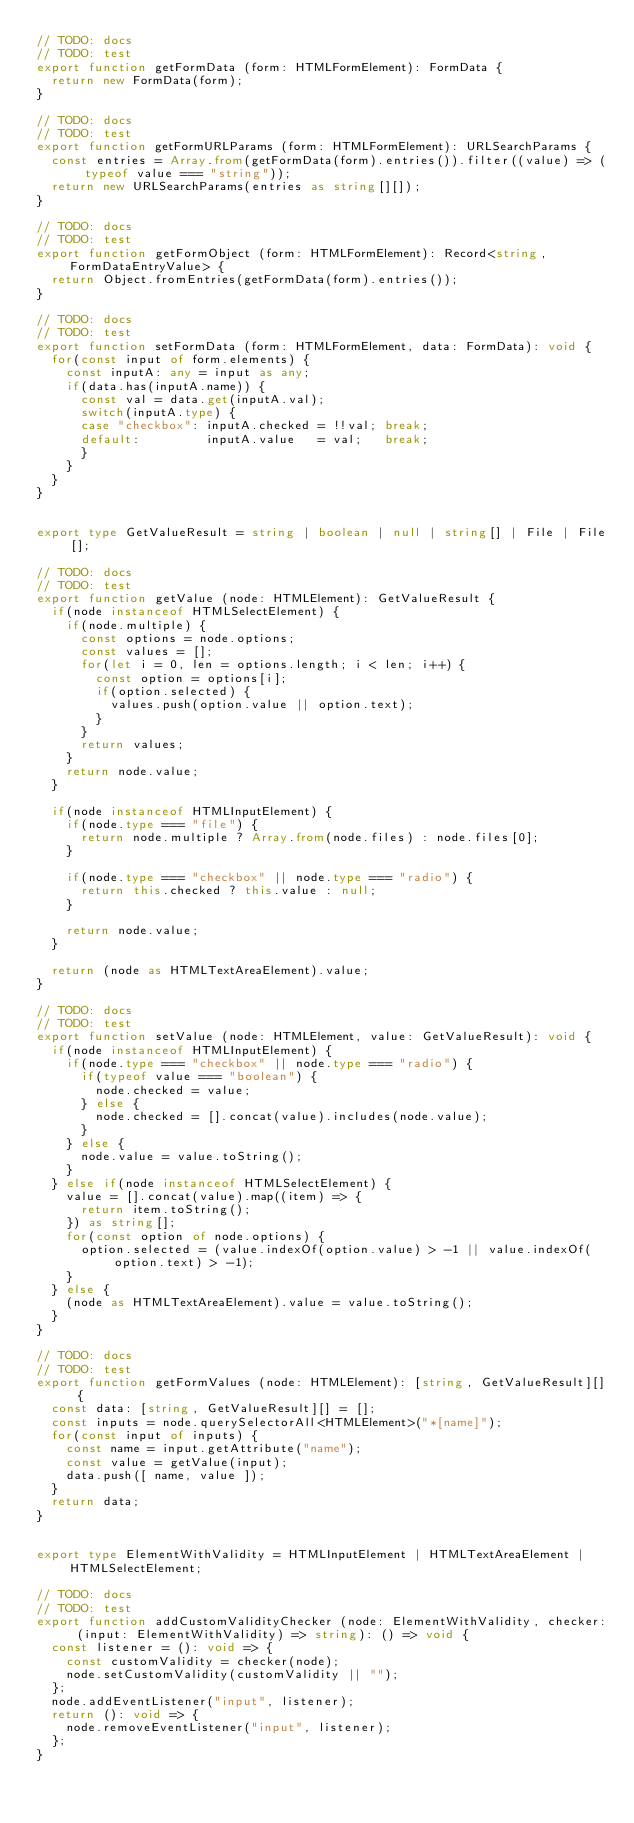Convert code to text. <code><loc_0><loc_0><loc_500><loc_500><_TypeScript_>// TODO: docs
// TODO: test
export function getFormData (form: HTMLFormElement): FormData {
  return new FormData(form);
}

// TODO: docs
// TODO: test
export function getFormURLParams (form: HTMLFormElement): URLSearchParams {
  const entries = Array.from(getFormData(form).entries()).filter((value) => (typeof value === "string"));
  return new URLSearchParams(entries as string[][]);
}

// TODO: docs
// TODO: test
export function getFormObject (form: HTMLFormElement): Record<string, FormDataEntryValue> {
  return Object.fromEntries(getFormData(form).entries());
}

// TODO: docs
// TODO: test
export function setFormData (form: HTMLFormElement, data: FormData): void {
  for(const input of form.elements) {
    const inputA: any = input as any;
    if(data.has(inputA.name)) {
      const val = data.get(inputA.val);
      switch(inputA.type) {
      case "checkbox": inputA.checked = !!val; break;
      default:         inputA.value   = val;   break;
      }
    }
  }
}


export type GetValueResult = string | boolean | null | string[] | File | File[];

// TODO: docs
// TODO: test
export function getValue (node: HTMLElement): GetValueResult {
  if(node instanceof HTMLSelectElement) {
    if(node.multiple) {
      const options = node.options;
      const values = [];
      for(let i = 0, len = options.length; i < len; i++) {
        const option = options[i];
        if(option.selected) {
          values.push(option.value || option.text);
        }
      }
      return values;
    }
    return node.value;
  }

  if(node instanceof HTMLInputElement) {
    if(node.type === "file") {
      return node.multiple ? Array.from(node.files) : node.files[0];
    }

    if(node.type === "checkbox" || node.type === "radio") {
      return this.checked ? this.value : null;
    }

    return node.value;
  }

  return (node as HTMLTextAreaElement).value;
}

// TODO: docs
// TODO: test
export function setValue (node: HTMLElement, value: GetValueResult): void {
  if(node instanceof HTMLInputElement) {
    if(node.type === "checkbox" || node.type === "radio") {
      if(typeof value === "boolean") {
        node.checked = value;
      } else {
        node.checked = [].concat(value).includes(node.value);
      }
    } else {
      node.value = value.toString();
    }
  } else if(node instanceof HTMLSelectElement) {
    value = [].concat(value).map((item) => {
      return item.toString();
    }) as string[];
    for(const option of node.options) {
      option.selected = (value.indexOf(option.value) > -1 || value.indexOf(option.text) > -1);
    }
  } else {
    (node as HTMLTextAreaElement).value = value.toString();
  }
}

// TODO: docs
// TODO: test
export function getFormValues (node: HTMLElement): [string, GetValueResult][] {
  const data: [string, GetValueResult][] = [];
  const inputs = node.querySelectorAll<HTMLElement>("*[name]");
  for(const input of inputs) {
    const name = input.getAttribute("name");
    const value = getValue(input);
    data.push([ name, value ]);
  }
  return data;
}


export type ElementWithValidity = HTMLInputElement | HTMLTextAreaElement | HTMLSelectElement;

// TODO: docs
// TODO: test
export function addCustomValidityChecker (node: ElementWithValidity, checker: (input: ElementWithValidity) => string): () => void {
  const listener = (): void => {
    const customValidity = checker(node);
    node.setCustomValidity(customValidity || "");
  };
  node.addEventListener("input", listener);
  return (): void => {
    node.removeEventListener("input", listener);
  };
}
</code> 